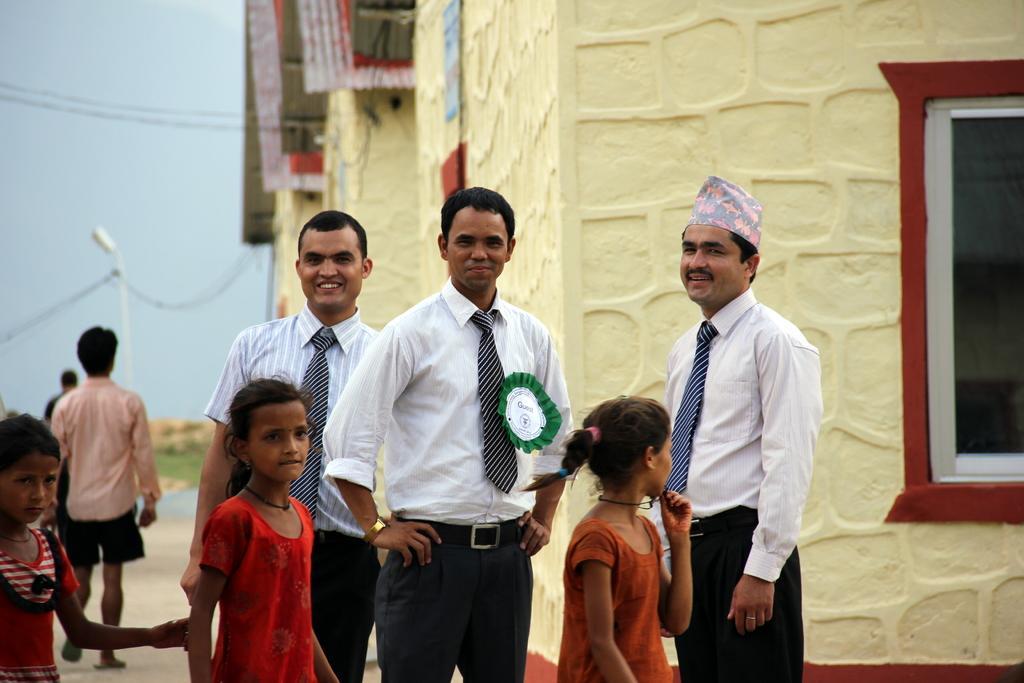Please provide a concise description of this image. As we can see in the image there are houses, window, street lamp, few people here and there and sky. 